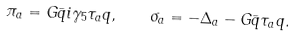Convert formula to latex. <formula><loc_0><loc_0><loc_500><loc_500>\pi _ { a } = G \bar { q } i \gamma _ { 5 } \tau _ { a } q , \quad \sigma _ { a } = - \Delta _ { a } - G \bar { q } \tau _ { a } q .</formula> 